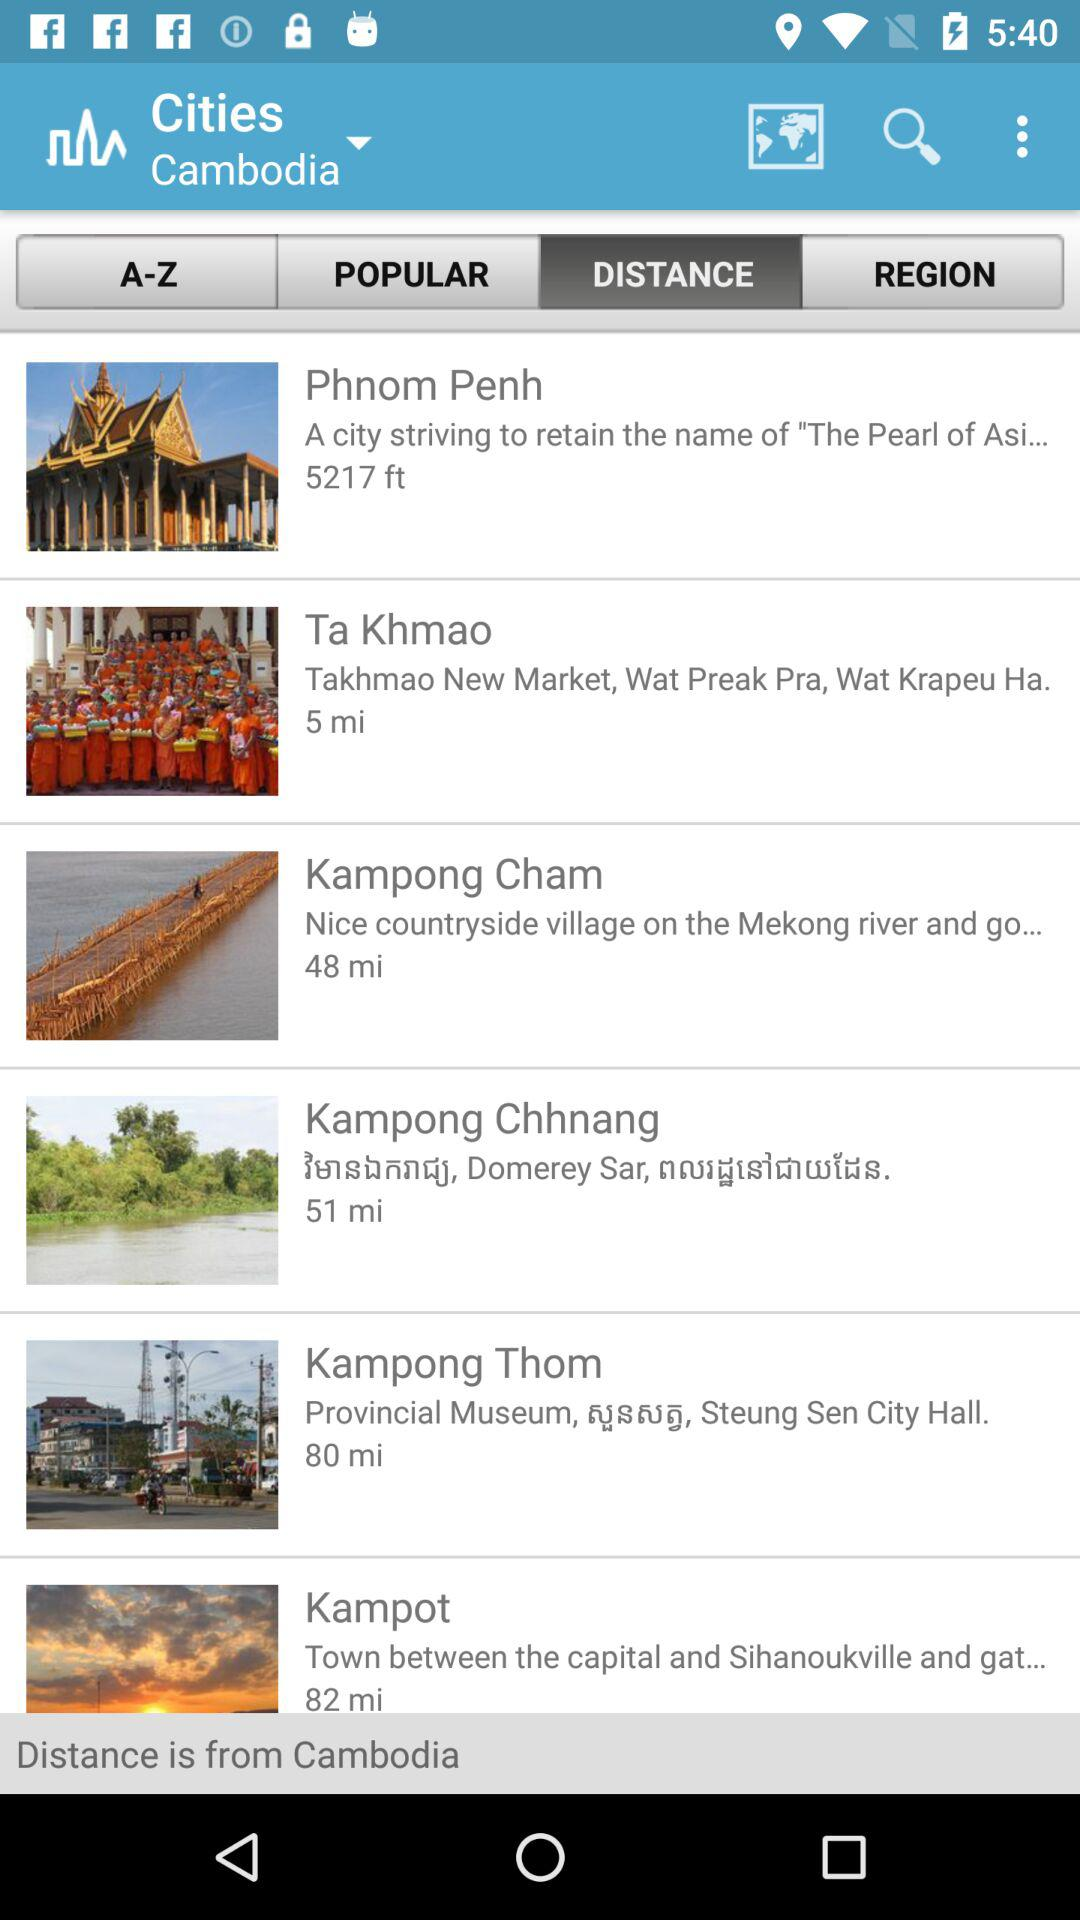How far away is Kampong Thom? Kampong Thom is 80 miles away. 